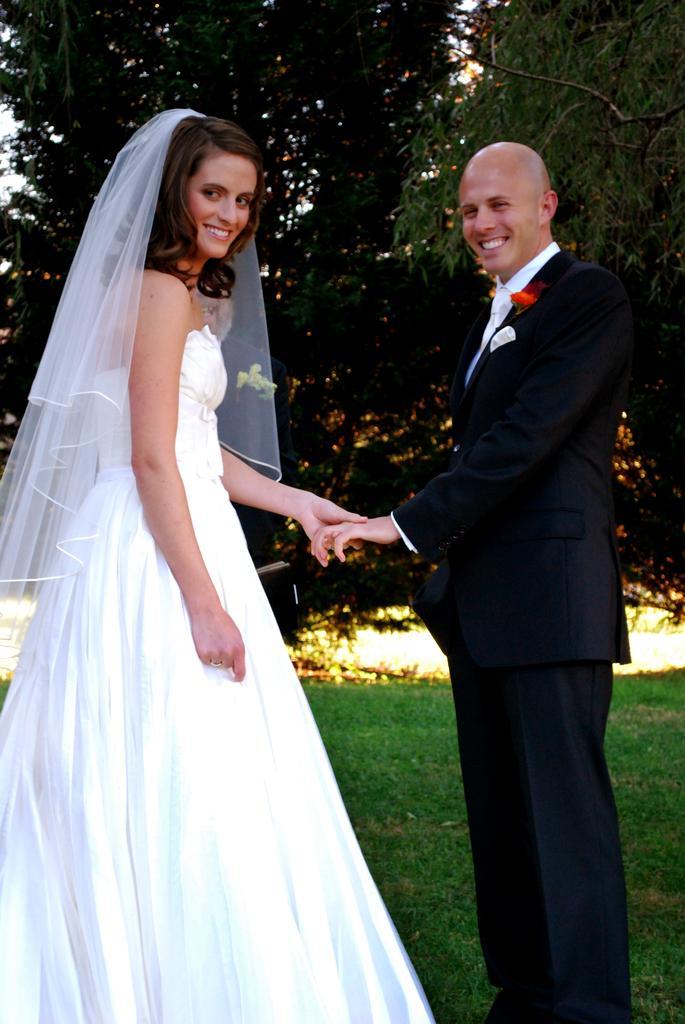Could you give a brief overview of what you see in this image? In this picture there is a woman with white dress is standing and smiling and she is holding the hand. There is a man with black suit is standing and smiling. At the back there are trees. At the top there is sky. At the bottom there is grass. 